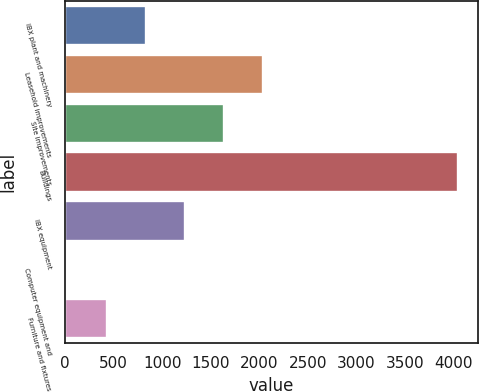<chart> <loc_0><loc_0><loc_500><loc_500><bar_chart><fcel>IBX plant and machinery<fcel>Leasehold improvements<fcel>Site improvements<fcel>Buildings<fcel>IBX equipment<fcel>Computer equipment and<fcel>Furniture and fixtures<nl><fcel>830<fcel>2037.5<fcel>1635<fcel>4050<fcel>1232.5<fcel>25<fcel>427.5<nl></chart> 